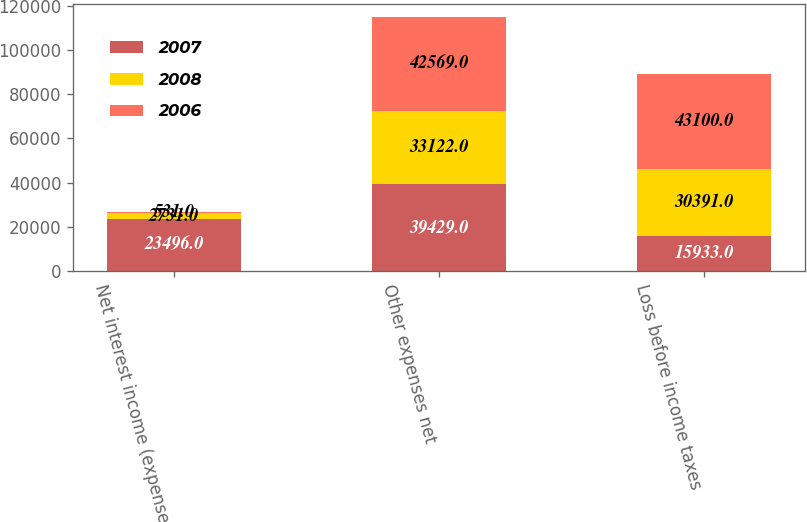<chart> <loc_0><loc_0><loc_500><loc_500><stacked_bar_chart><ecel><fcel>Net interest income (expense)<fcel>Other expenses net<fcel>Loss before income taxes<nl><fcel>2007<fcel>23496<fcel>39429<fcel>15933<nl><fcel>2008<fcel>2731<fcel>33122<fcel>30391<nl><fcel>2006<fcel>531<fcel>42569<fcel>43100<nl></chart> 